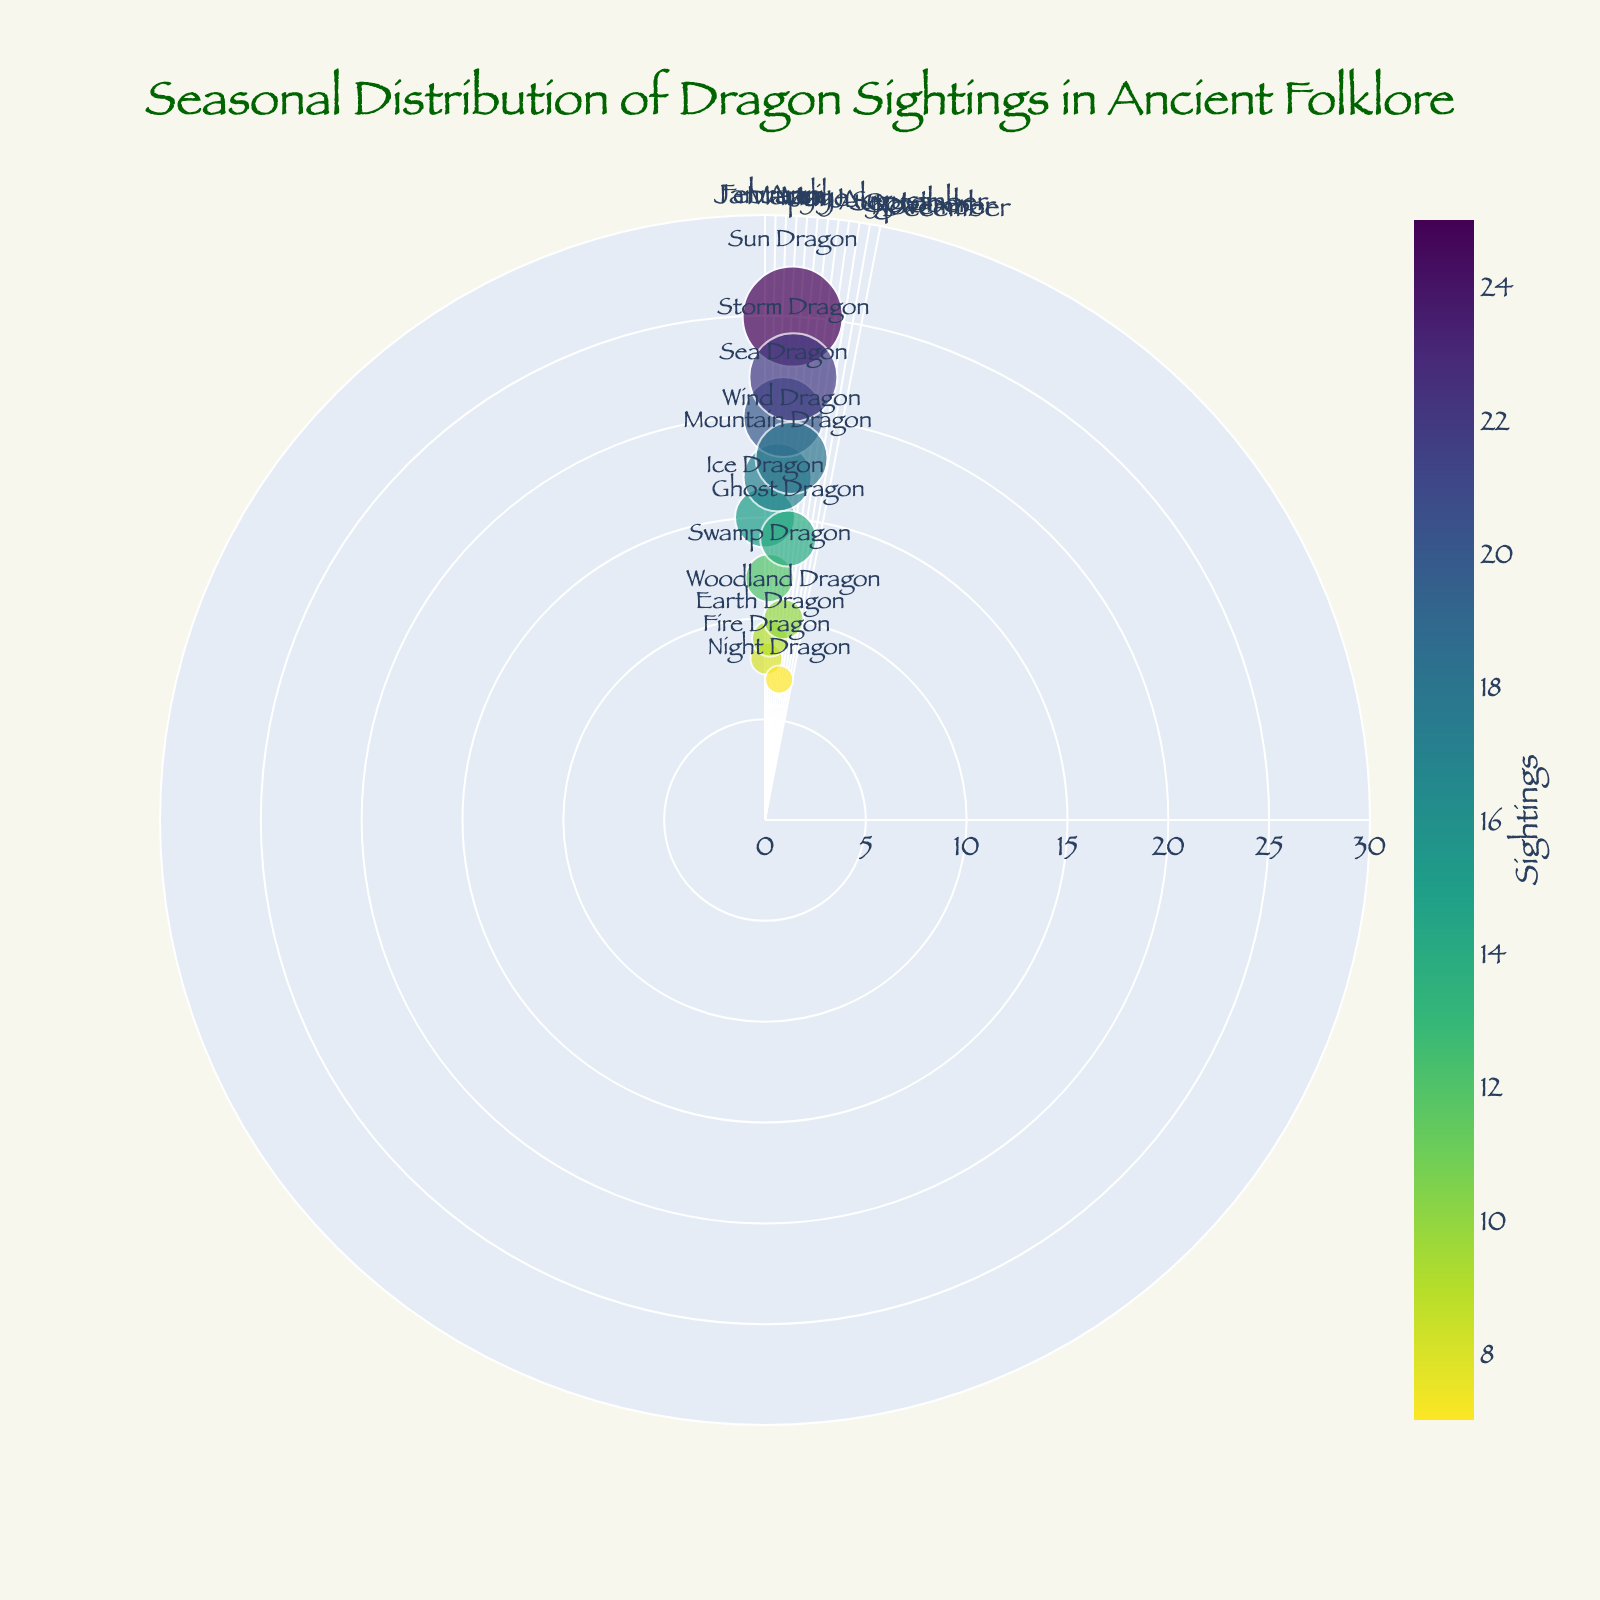What is the title of the figure? The title is usually displayed at the top of the figure. Here, it reads "Seasonal Distribution of Dragon Sightings in Ancient Folklore."
Answer: Seasonal Distribution of Dragon Sightings in Ancient Folklore Which type of dragon has the highest number of sightings? To determine this, look for the dragon type with the largest marker size and the highest value on the radial axis. The Sun Dragon in July has the most sightings with 25.
Answer: Sun Dragon What is the total number of dragon sightings in December? Find December on the chart and read the corresponding sighting value, which is 7 for the Night Dragon.
Answer: 7 How does the number of Ice Dragon sightings in January compare to the number of Fire Dragon sightings in February? Compare the radial axis values for January and February. January has 15 sightings for the Ice Dragon, while February has 8 sightings for the Fire Dragon. 15 is greater than 8.
Answer: 15 is greater than 8 What is the average number of dragon sightings over the summer months (June, July, August)? Add the sightings for June (20 for Sea Dragon), July (25 for Sun Dragon), and August (22 for Storm Dragon), then divide by 3. (20 + 25 + 22) / 3 = 67 / 3 = 22.33
Answer: 22.33 Which dragon type has the fewest sightings and in which month does this occur? Find the smallest marker size and the lowest value on the radial axis. The Night Dragon in December has the fewest sightings with 7.
Answer: Night Dragon in December What is the range of dragon sightings throughout the year? Subtract the minimum number of sightings from the maximum number. The maximum is 25 (Sun Dragon in July) and the minimum is 7 (Night Dragon in December). 25 - 7 = 18
Answer: 18 Which month has a notable increase in dragon sightings compared to its previous month? Compare adjacent months to see where a significant increase occurs. Notable increases can be seen from April (9) to May (17) and from June (20) to July (25).
Answer: April to May and June to July How many types of dragons are sighted during the autumn months (September, October, November)? Identify the dragon types for September (Wind Dragon), October (Ghost Dragon), and November (Woodland Dragon), which total three unique dragon types.
Answer: 3 What is the total number of dragon sightings in spring (March, April, May)? Add the sightings for March (12 for Swamp Dragon), April (9 for Earth Dragon), and May (17 for Mountain Dragon). 12 + 9 + 17 = 38
Answer: 38 